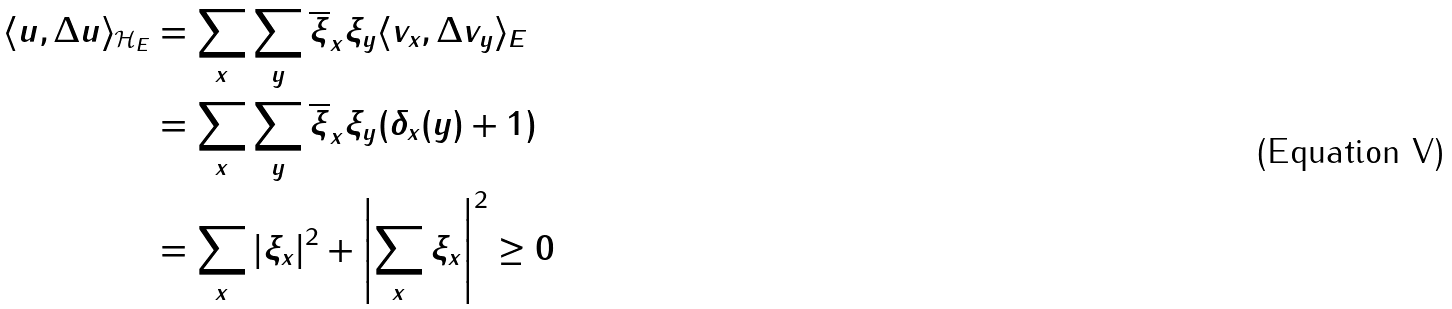<formula> <loc_0><loc_0><loc_500><loc_500>\langle u , \Delta u \rangle _ { \mathcal { H } _ { E } } & = \sum _ { x } \sum _ { y } \overline { \xi } _ { x } \xi _ { y } \langle v _ { x } , \Delta v _ { y } \rangle _ { E } \\ & = \sum _ { x } \sum _ { y } \overline { \xi } _ { x } \xi _ { y } ( \delta _ { x } ( y ) + 1 ) \\ & = \sum _ { x } | \xi _ { x } | ^ { 2 } + \left | \sum _ { x } \xi _ { x } \right | ^ { 2 } \geq 0</formula> 